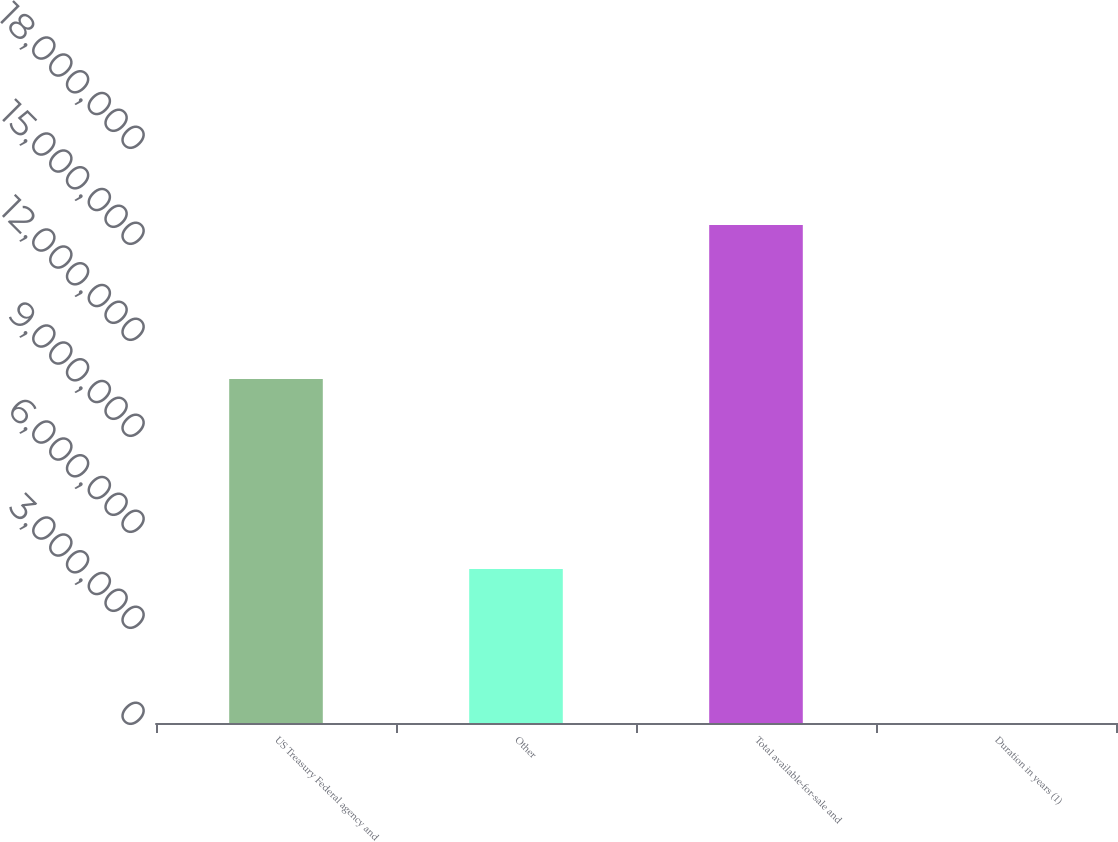Convert chart to OTSL. <chart><loc_0><loc_0><loc_500><loc_500><bar_chart><fcel>US Treasury Federal agency and<fcel>Other<fcel>Total available-for-sale and<fcel>Duration in years (1)<nl><fcel>1.07524e+07<fcel>4.81046e+06<fcel>1.55628e+07<fcel>4.7<nl></chart> 